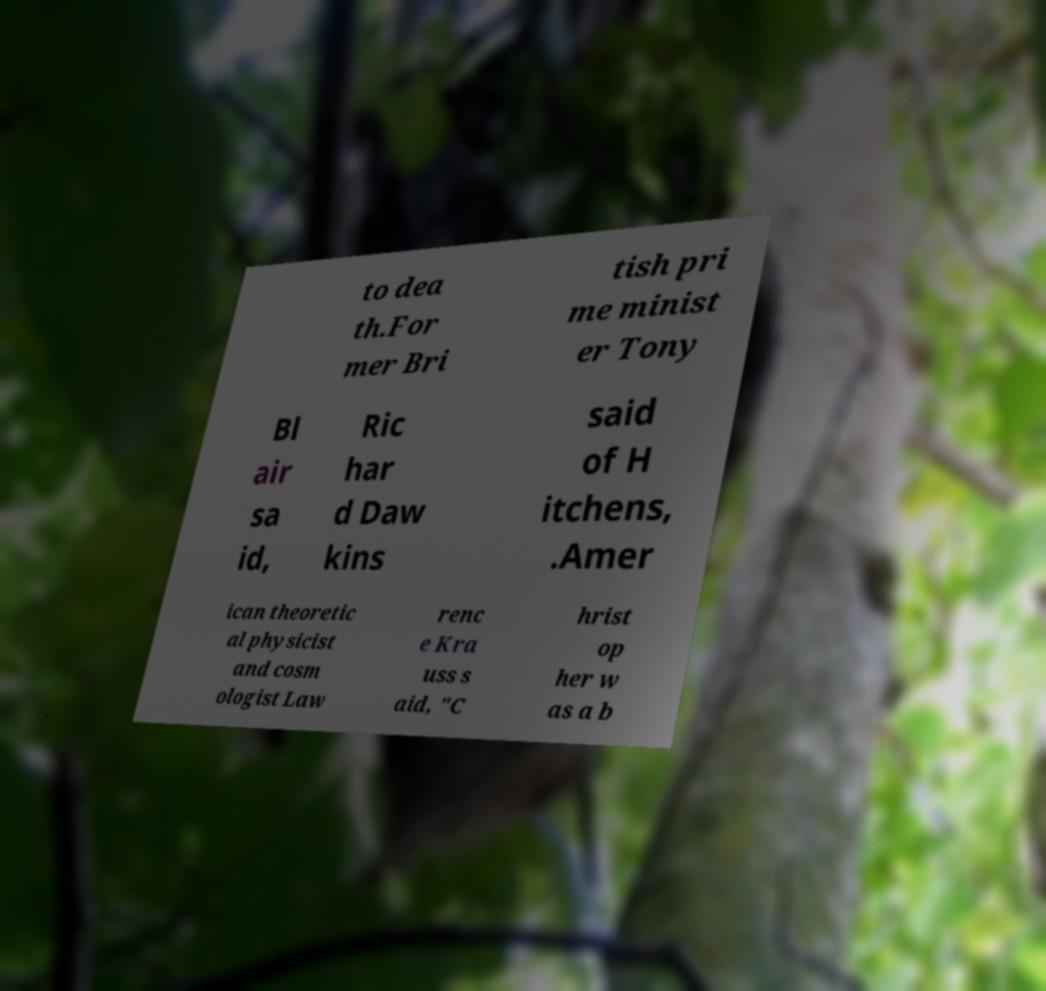Could you assist in decoding the text presented in this image and type it out clearly? to dea th.For mer Bri tish pri me minist er Tony Bl air sa id, Ric har d Daw kins said of H itchens, .Amer ican theoretic al physicist and cosm ologist Law renc e Kra uss s aid, "C hrist op her w as a b 